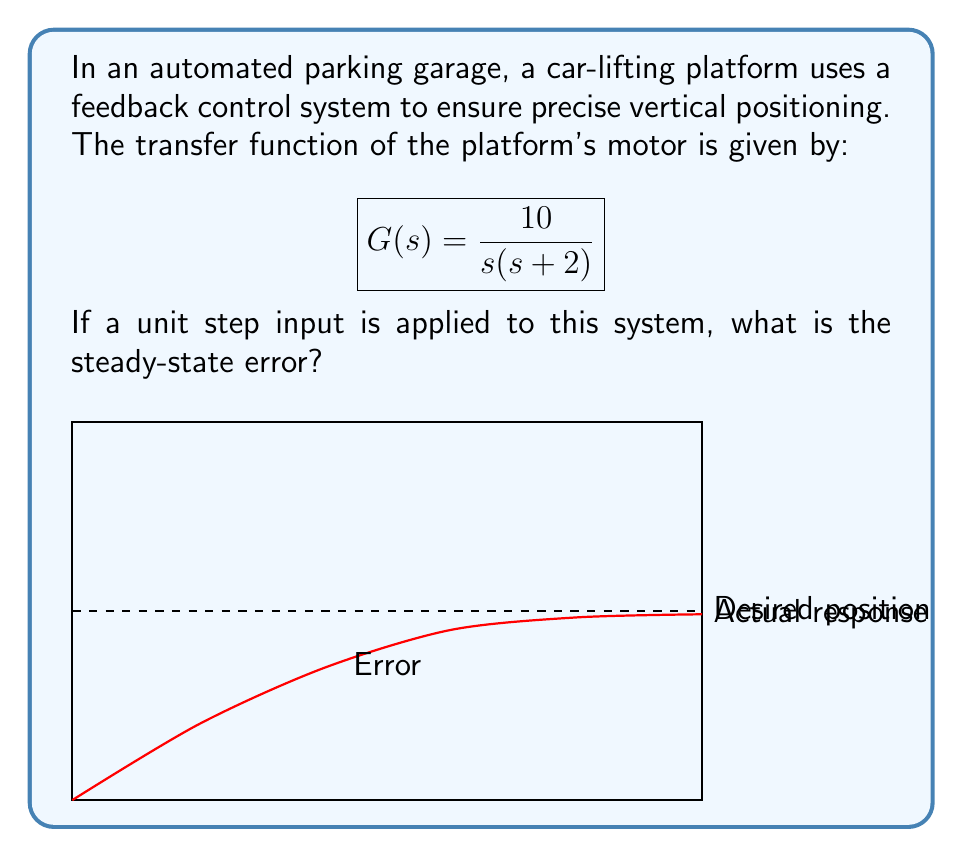Can you solve this math problem? To find the steady-state error for a step input, we need to follow these steps:

1) First, recall that the steady-state error for a step input is given by:

   $$e_{ss} = \lim_{s \to 0} \frac{s}{1 + G(s)H(s)}$$

   where $H(s) = 1$ for a unity feedback system.

2) Substitute the given transfer function:

   $$e_{ss} = \lim_{s \to 0} \frac{s}{1 + \frac{10}{s(s + 2)}}$$

3) Simplify the denominator:

   $$e_{ss} = \lim_{s \to 0} \frac{s^2(s + 2)}{s^2(s + 2) + 10}$$

4) As $s$ approaches 0, the higher order terms become negligible:

   $$e_{ss} = \lim_{s \to 0} \frac{0}{0 + 10} = 0$$

5) Therefore, the steady-state error is 0, meaning the system will eventually reach the desired position with no permanent offset.

This result indicates that the automated parking system will accurately position the car-lifting platform at the desired level in the long term, ensuring precise parking operations.
Answer: 0 